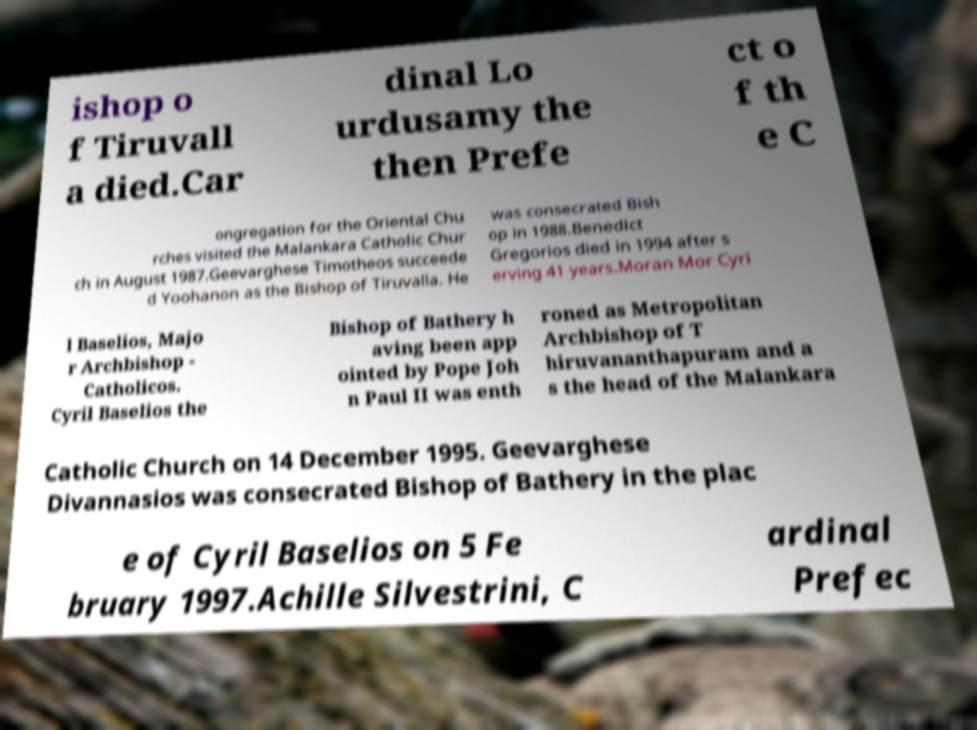What messages or text are displayed in this image? I need them in a readable, typed format. ishop o f Tiruvall a died.Car dinal Lo urdusamy the then Prefe ct o f th e C ongregation for the Oriental Chu rches visited the Malankara Catholic Chur ch in August 1987.Geevarghese Timotheos succeede d Yoohanon as the Bishop of Tiruvalla. He was consecrated Bish op in 1988.Benedict Gregorios died in 1994 after s erving 41 years.Moran Mor Cyri l Baselios, Majo r Archbishop - Catholicos. Cyril Baselios the Bishop of Bathery h aving been app ointed by Pope Joh n Paul II was enth roned as Metropolitan Archbishop of T hiruvananthapuram and a s the head of the Malankara Catholic Church on 14 December 1995. Geevarghese Divannasios was consecrated Bishop of Bathery in the plac e of Cyril Baselios on 5 Fe bruary 1997.Achille Silvestrini, C ardinal Prefec 